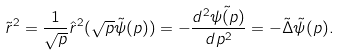<formula> <loc_0><loc_0><loc_500><loc_500>\tilde { r } ^ { 2 } = \frac { 1 } { \sqrt { p } } \hat { r } ^ { 2 } ( \sqrt { p } \tilde { \psi } ( p ) ) = - \frac { d ^ { 2 } \tilde { \psi ( p ) } } { d p ^ { 2 } } = - \tilde { \Delta } \tilde { \psi } ( p ) .</formula> 